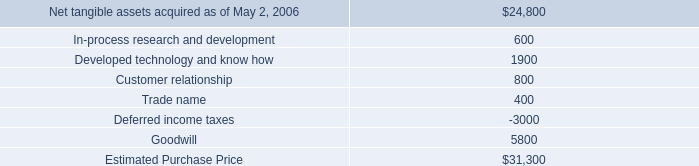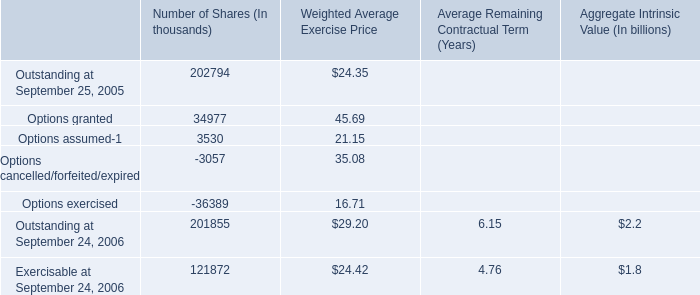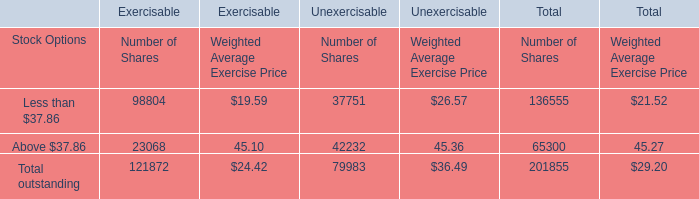What's the 200% of the Number of Shares for Stock Options Less than $37.86 for Total? 
Computations: (2 * 136555)
Answer: 273110.0. 